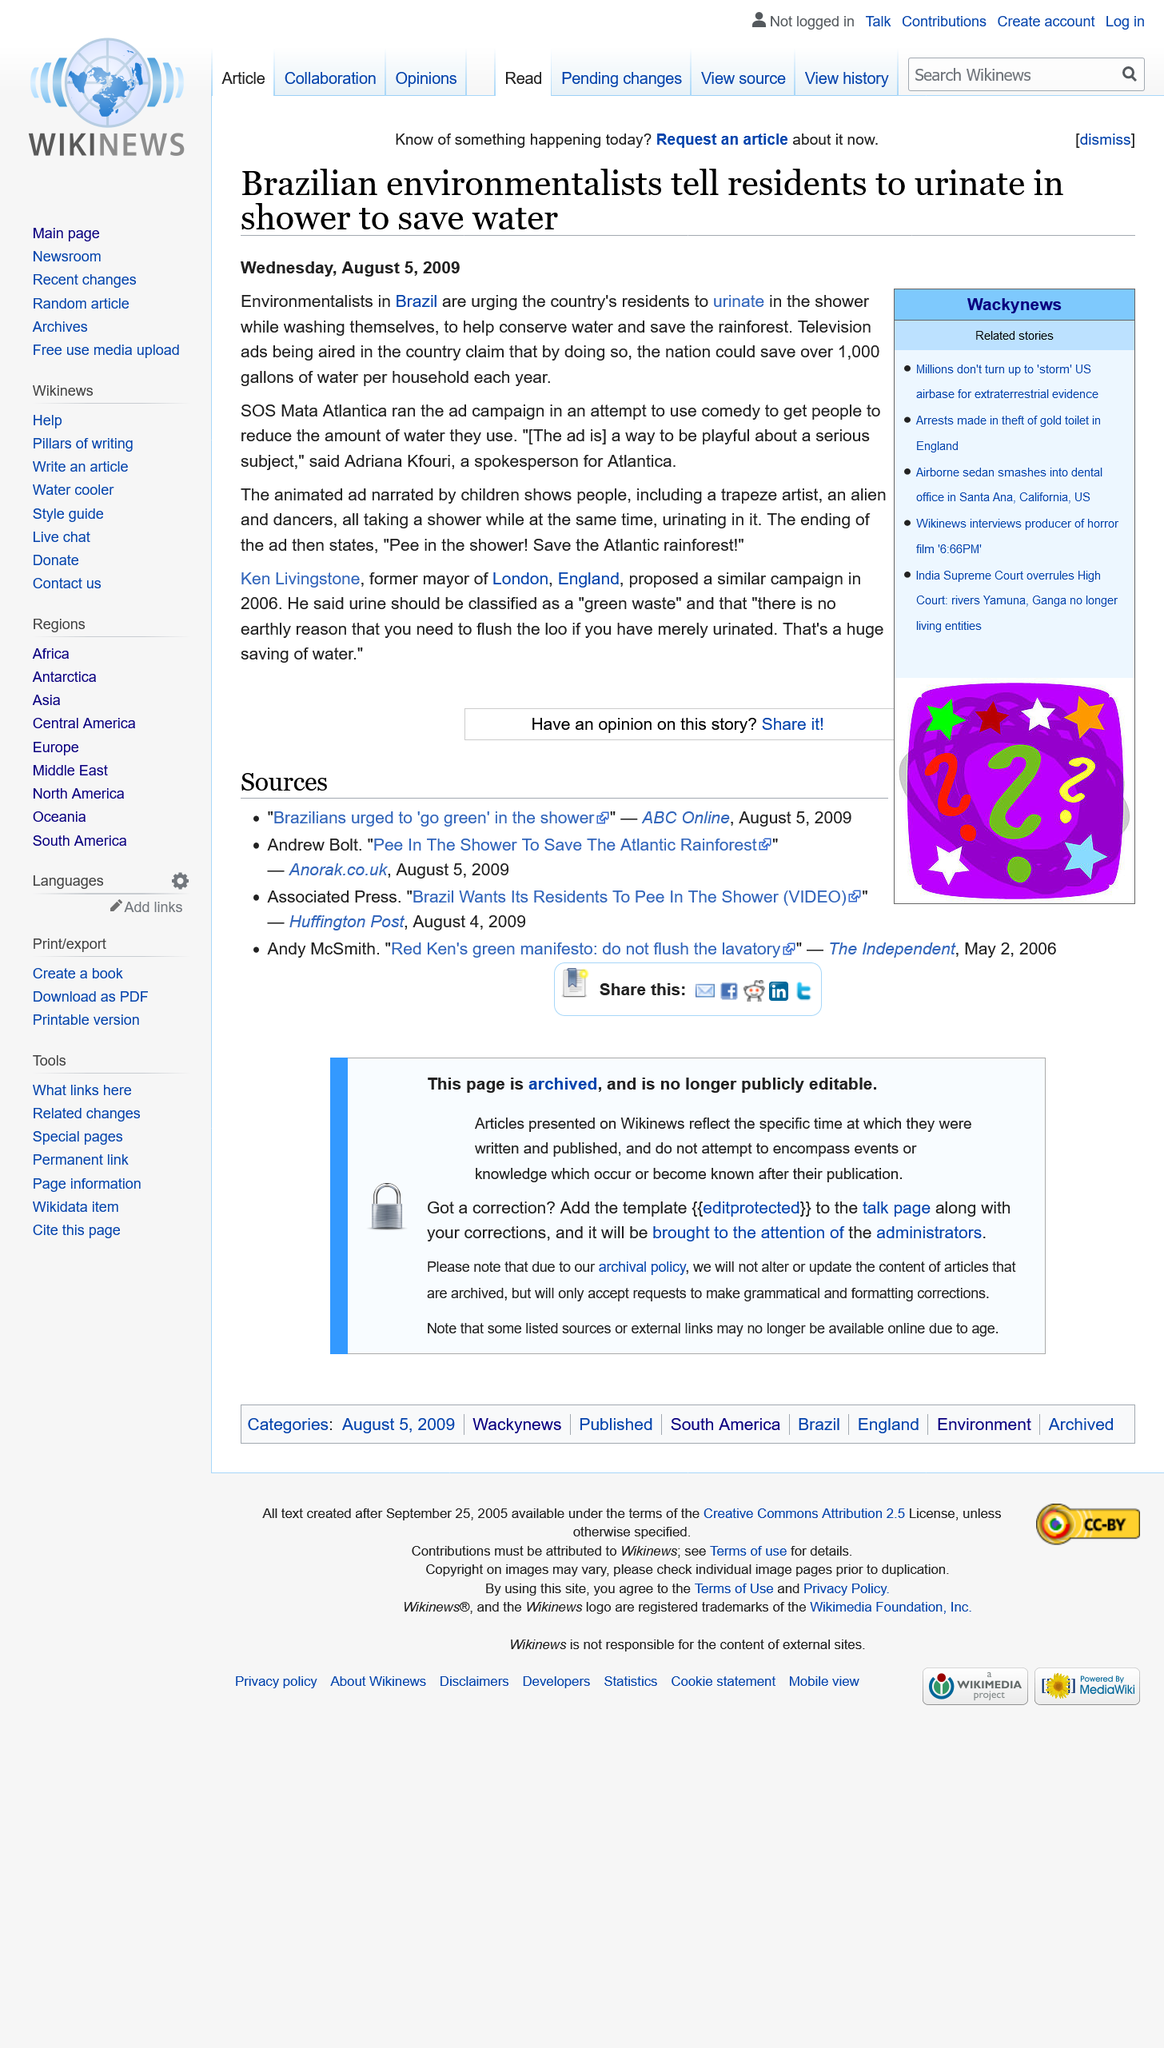Mention a couple of crucial points in this snapshot. The ad that stated "Pee in the shower!" aired in Brazil. Adriana Kfouri was the spokesperson for SOS Mata Atlantica. The organization SOS Mata Atlantica aired an ad campaign urging Brazilian residents to urinate in the shower while washing themselves. 